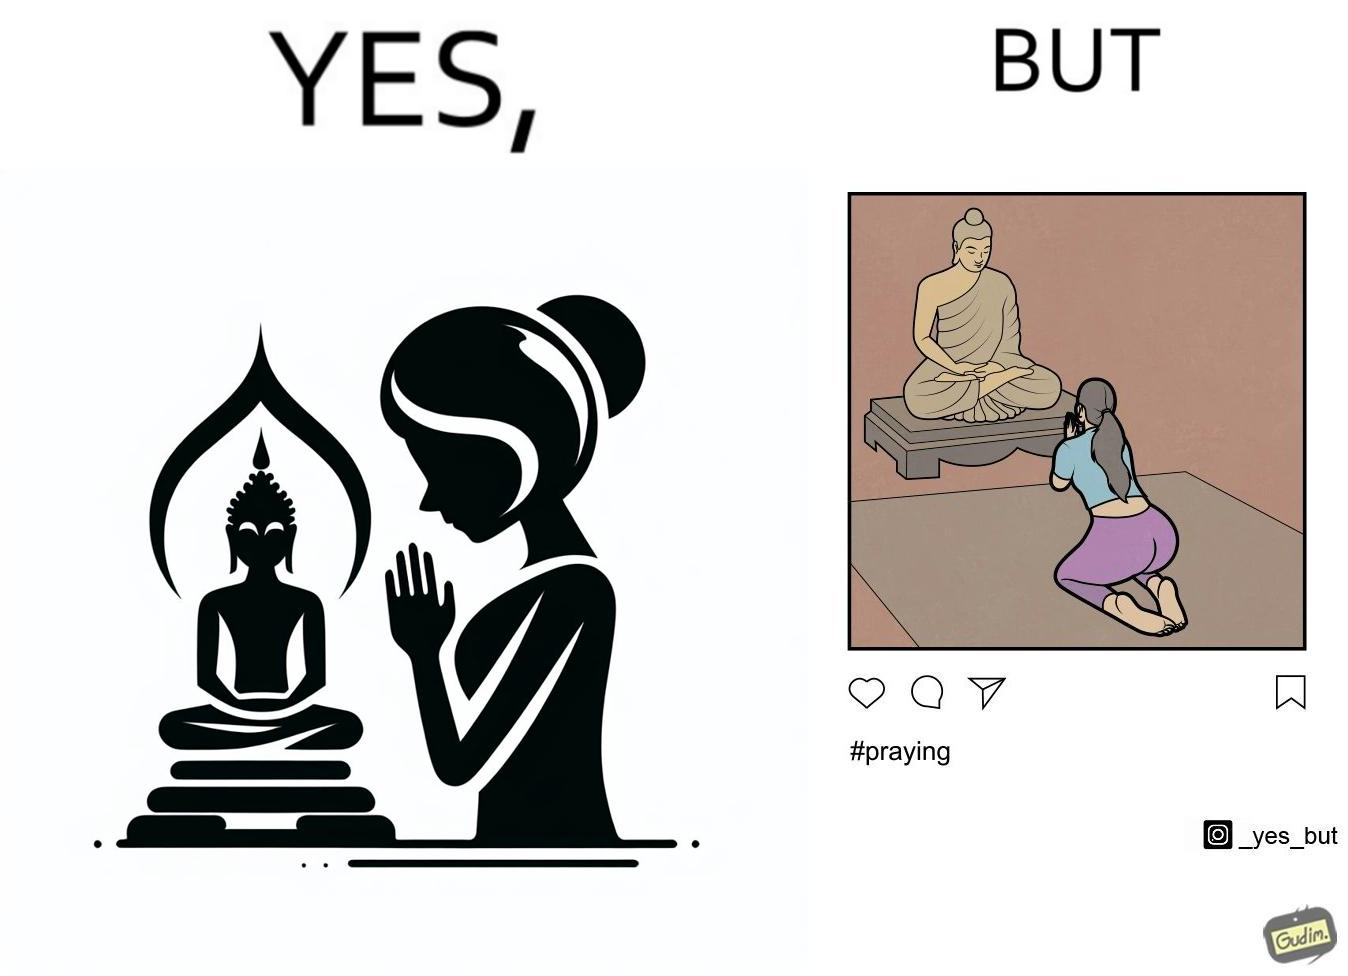Describe the content of this image. The image is ironic, because in the first image it seems that the woman is praying whole heartedly by bowing down in front of the statue but in the second image the same image is seen posted on the internet, so the woman was just posing for a photo to be posted on internet to gain followers or likes 